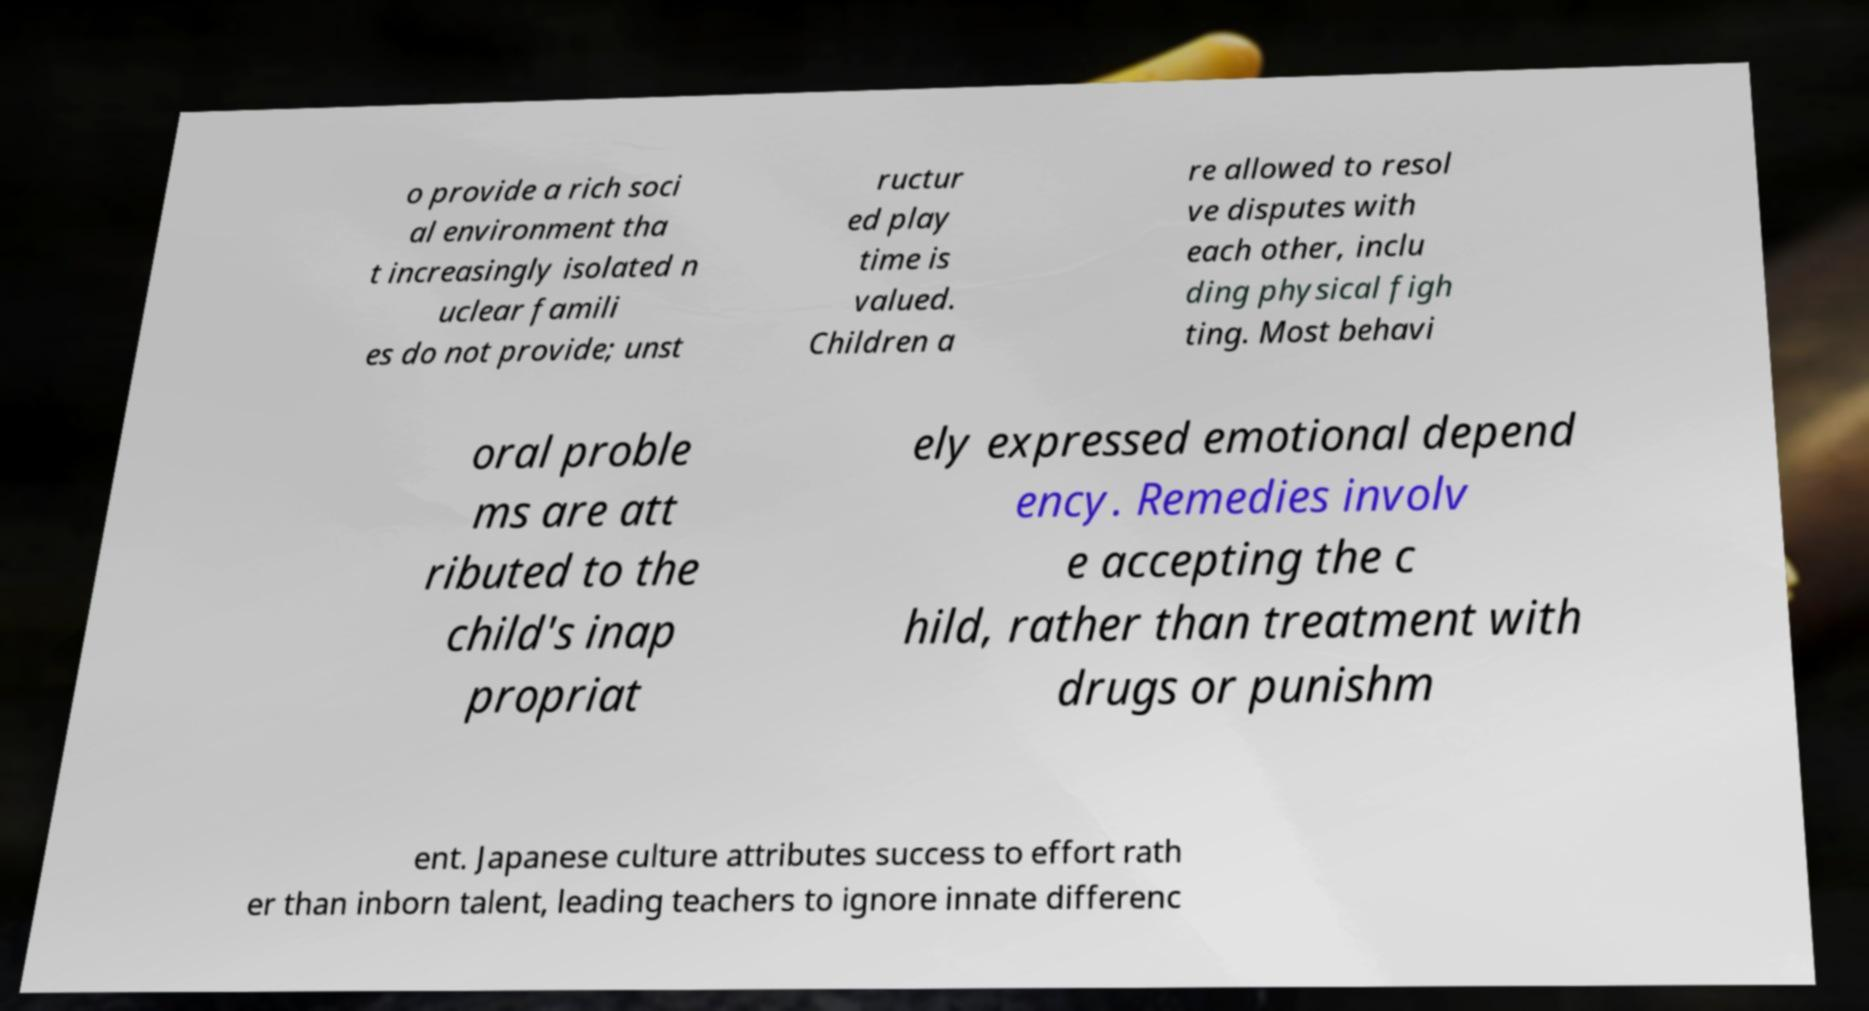What messages or text are displayed in this image? I need them in a readable, typed format. o provide a rich soci al environment tha t increasingly isolated n uclear famili es do not provide; unst ructur ed play time is valued. Children a re allowed to resol ve disputes with each other, inclu ding physical figh ting. Most behavi oral proble ms are att ributed to the child's inap propriat ely expressed emotional depend ency. Remedies involv e accepting the c hild, rather than treatment with drugs or punishm ent. Japanese culture attributes success to effort rath er than inborn talent, leading teachers to ignore innate differenc 